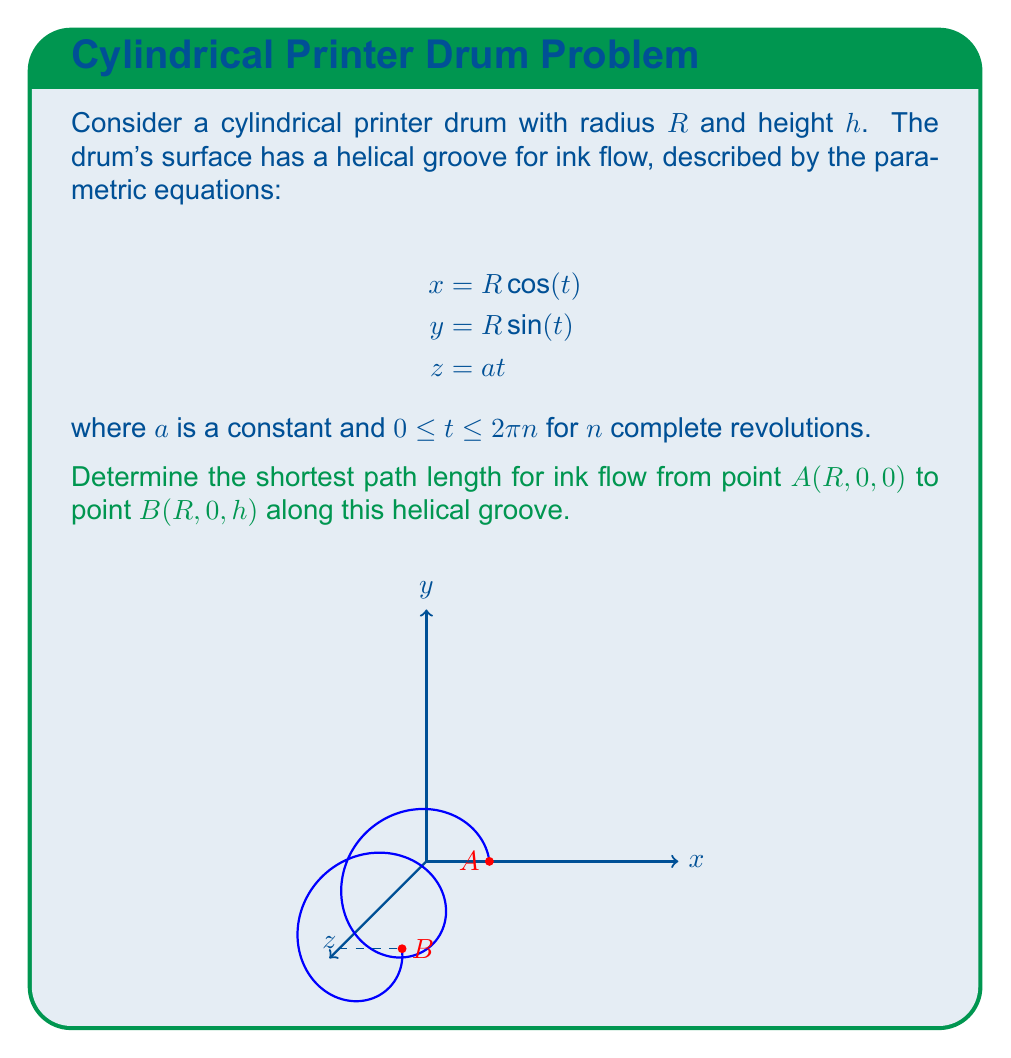Show me your answer to this math problem. To solve this problem, we'll follow these steps:

1) The helical path on the cylinder's surface can be described by the arc length formula for a parametric curve:

   $$L = \int_0^T \sqrt{\left(\frac{dx}{dt}\right)^2 + \left(\frac{dy}{dt}\right)^2 + \left(\frac{dz}{dt}\right)^2} dt$$

2) Let's calculate the derivatives:
   $$\frac{dx}{dt} = -R \sin(t)$$
   $$\frac{dy}{dt} = R \cos(t)$$
   $$\frac{dz}{dt} = a$$

3) Substituting these into the arc length formula:

   $$L = \int_0^T \sqrt{R^2\sin^2(t) + R^2\cos^2(t) + a^2} dt$$

4) Simplify using the identity $\sin^2(t) + \cos^2(t) = 1$:

   $$L = \int_0^T \sqrt{R^2 + a^2} dt$$

5) The square root term is constant, so we can take it out of the integral:

   $$L = \sqrt{R^2 + a^2} \int_0^T dt = \sqrt{R^2 + a^2} \cdot T$$

6) To find $T$, note that we need to go from $z=0$ to $z=h$. Using the equation $z = at$, we get:

   $$h = aT$$
   $$T = \frac{h}{a}$$

7) Substituting this back into our length formula:

   $$L = \sqrt{R^2 + a^2} \cdot \frac{h}{a}$$

8) To find the shortest path, we need to minimize $L$ with respect to $a$. Taking the derivative and setting it to zero:

   $$\frac{dL}{da} = \frac{a}{\sqrt{R^2 + a^2}} \cdot \frac{h}{a} - \sqrt{R^2 + a^2} \cdot \frac{h}{a^2} = 0$$

9) Solving this equation, we find that $L$ is minimized when $a = R$.

10) Therefore, the shortest path length is:

    $$L_{min} = \sqrt{R^2 + R^2} \cdot \frac{h}{R} = \sqrt{2} \cdot h$$
Answer: $\sqrt{2} \cdot h$ 